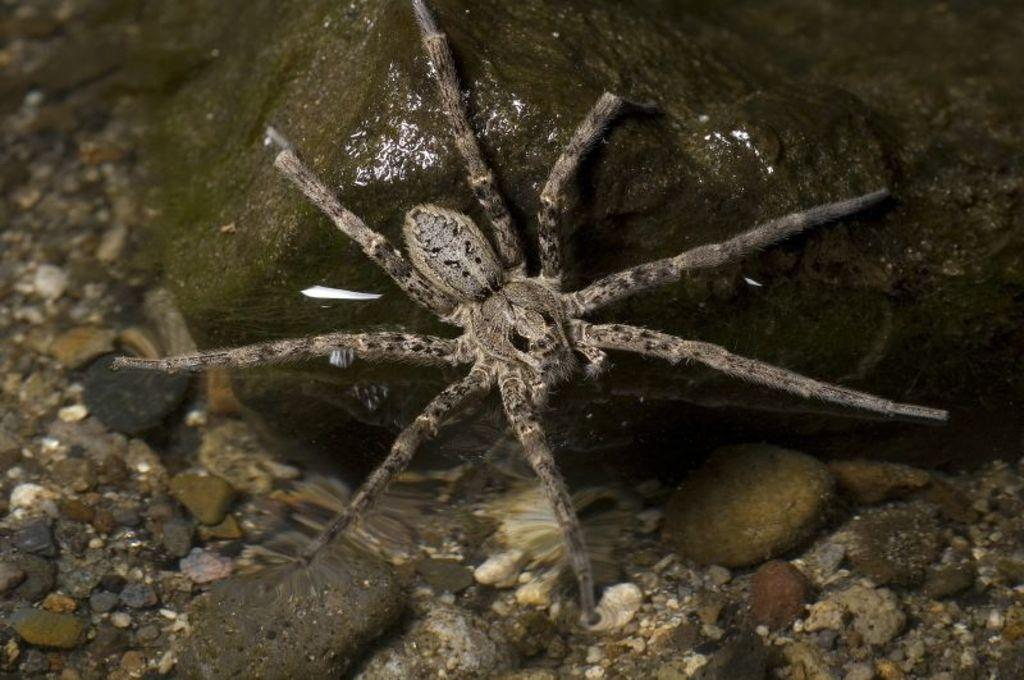What is the main subject in the center of the image? There is an insect in the center of the image. What is the insect resting on? The insect is on a rock. What type of small stones can be seen at the bottom of the image? There are pebbles at the bottom side of the image. Can you tell me how many fish are swimming in the image? There are no fish present in the image; it features an insect on a rock with pebbles at the bottom. What type of respect is shown by the insect in the image? There is no indication of respect or any interaction between the insect and other subjects in the image. 